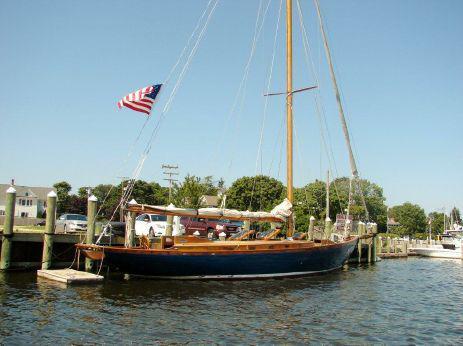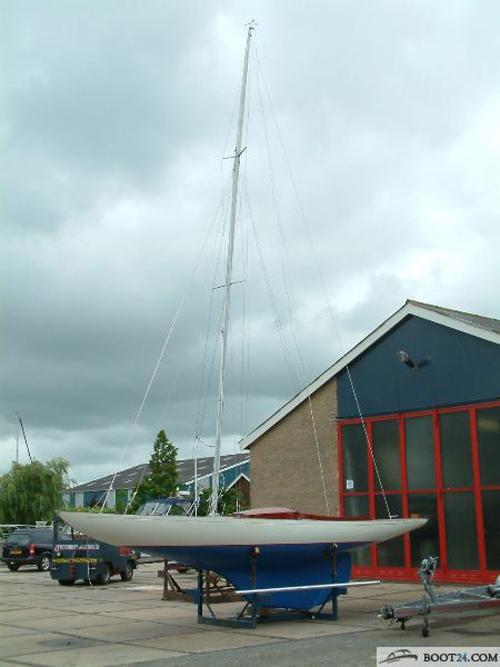The first image is the image on the left, the second image is the image on the right. Assess this claim about the two images: "One sailboat is sitting on a platform on dry land, while a second sailboat is floating on water.". Correct or not? Answer yes or no. Yes. The first image is the image on the left, the second image is the image on the right. For the images displayed, is the sentence "The left and right image contains the same number of sailboats with there sails down." factually correct? Answer yes or no. Yes. 